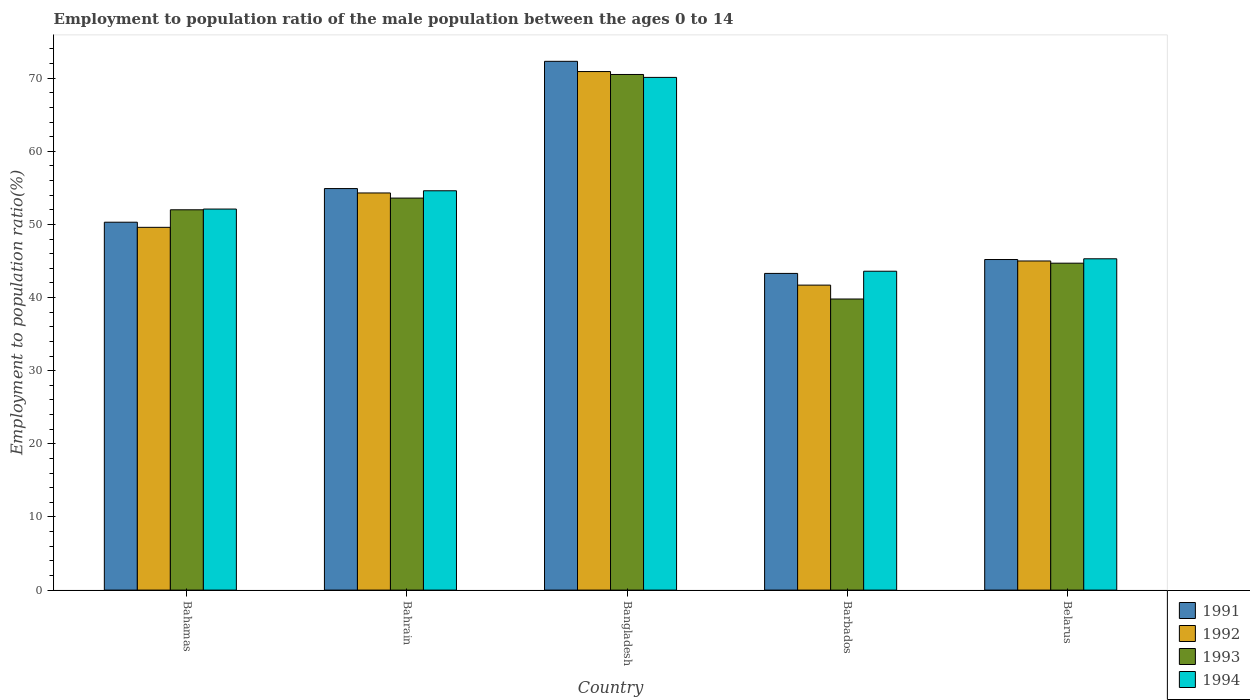Are the number of bars per tick equal to the number of legend labels?
Your answer should be very brief. Yes. Are the number of bars on each tick of the X-axis equal?
Ensure brevity in your answer.  Yes. How many bars are there on the 4th tick from the left?
Offer a very short reply. 4. What is the employment to population ratio in 1991 in Barbados?
Provide a succinct answer. 43.3. Across all countries, what is the maximum employment to population ratio in 1992?
Make the answer very short. 70.9. Across all countries, what is the minimum employment to population ratio in 1993?
Offer a terse response. 39.8. In which country was the employment to population ratio in 1993 maximum?
Your answer should be very brief. Bangladesh. In which country was the employment to population ratio in 1993 minimum?
Ensure brevity in your answer.  Barbados. What is the total employment to population ratio in 1994 in the graph?
Your answer should be very brief. 265.7. What is the difference between the employment to population ratio in 1993 in Bahrain and that in Belarus?
Keep it short and to the point. 8.9. What is the difference between the employment to population ratio in 1993 in Barbados and the employment to population ratio in 1992 in Belarus?
Make the answer very short. -5.2. What is the average employment to population ratio in 1991 per country?
Your answer should be compact. 53.2. What is the difference between the employment to population ratio of/in 1992 and employment to population ratio of/in 1991 in Belarus?
Your response must be concise. -0.2. In how many countries, is the employment to population ratio in 1991 greater than 56 %?
Offer a very short reply. 1. What is the ratio of the employment to population ratio in 1991 in Barbados to that in Belarus?
Your answer should be compact. 0.96. What is the difference between the highest and the second highest employment to population ratio in 1993?
Your response must be concise. -1.6. What is the difference between the highest and the lowest employment to population ratio in 1994?
Your response must be concise. 26.5. In how many countries, is the employment to population ratio in 1992 greater than the average employment to population ratio in 1992 taken over all countries?
Provide a short and direct response. 2. Is it the case that in every country, the sum of the employment to population ratio in 1992 and employment to population ratio in 1991 is greater than the sum of employment to population ratio in 1993 and employment to population ratio in 1994?
Your response must be concise. No. What does the 1st bar from the left in Barbados represents?
Give a very brief answer. 1991. Does the graph contain any zero values?
Provide a succinct answer. No. How many legend labels are there?
Your answer should be very brief. 4. How are the legend labels stacked?
Your answer should be compact. Vertical. What is the title of the graph?
Your response must be concise. Employment to population ratio of the male population between the ages 0 to 14. Does "1979" appear as one of the legend labels in the graph?
Your answer should be very brief. No. What is the label or title of the X-axis?
Provide a short and direct response. Country. What is the label or title of the Y-axis?
Offer a terse response. Employment to population ratio(%). What is the Employment to population ratio(%) in 1991 in Bahamas?
Provide a succinct answer. 50.3. What is the Employment to population ratio(%) of 1992 in Bahamas?
Offer a terse response. 49.6. What is the Employment to population ratio(%) of 1993 in Bahamas?
Provide a succinct answer. 52. What is the Employment to population ratio(%) in 1994 in Bahamas?
Your answer should be very brief. 52.1. What is the Employment to population ratio(%) in 1991 in Bahrain?
Provide a succinct answer. 54.9. What is the Employment to population ratio(%) of 1992 in Bahrain?
Offer a very short reply. 54.3. What is the Employment to population ratio(%) of 1993 in Bahrain?
Provide a succinct answer. 53.6. What is the Employment to population ratio(%) in 1994 in Bahrain?
Give a very brief answer. 54.6. What is the Employment to population ratio(%) of 1991 in Bangladesh?
Provide a succinct answer. 72.3. What is the Employment to population ratio(%) in 1992 in Bangladesh?
Give a very brief answer. 70.9. What is the Employment to population ratio(%) in 1993 in Bangladesh?
Your answer should be very brief. 70.5. What is the Employment to population ratio(%) in 1994 in Bangladesh?
Make the answer very short. 70.1. What is the Employment to population ratio(%) in 1991 in Barbados?
Provide a short and direct response. 43.3. What is the Employment to population ratio(%) in 1992 in Barbados?
Provide a short and direct response. 41.7. What is the Employment to population ratio(%) of 1993 in Barbados?
Keep it short and to the point. 39.8. What is the Employment to population ratio(%) of 1994 in Barbados?
Your answer should be compact. 43.6. What is the Employment to population ratio(%) of 1991 in Belarus?
Your response must be concise. 45.2. What is the Employment to population ratio(%) of 1993 in Belarus?
Offer a very short reply. 44.7. What is the Employment to population ratio(%) of 1994 in Belarus?
Keep it short and to the point. 45.3. Across all countries, what is the maximum Employment to population ratio(%) in 1991?
Keep it short and to the point. 72.3. Across all countries, what is the maximum Employment to population ratio(%) in 1992?
Make the answer very short. 70.9. Across all countries, what is the maximum Employment to population ratio(%) in 1993?
Offer a terse response. 70.5. Across all countries, what is the maximum Employment to population ratio(%) of 1994?
Your answer should be very brief. 70.1. Across all countries, what is the minimum Employment to population ratio(%) in 1991?
Provide a short and direct response. 43.3. Across all countries, what is the minimum Employment to population ratio(%) in 1992?
Keep it short and to the point. 41.7. Across all countries, what is the minimum Employment to population ratio(%) in 1993?
Give a very brief answer. 39.8. Across all countries, what is the minimum Employment to population ratio(%) of 1994?
Give a very brief answer. 43.6. What is the total Employment to population ratio(%) of 1991 in the graph?
Offer a very short reply. 266. What is the total Employment to population ratio(%) of 1992 in the graph?
Give a very brief answer. 261.5. What is the total Employment to population ratio(%) of 1993 in the graph?
Keep it short and to the point. 260.6. What is the total Employment to population ratio(%) of 1994 in the graph?
Give a very brief answer. 265.7. What is the difference between the Employment to population ratio(%) of 1991 in Bahamas and that in Bahrain?
Provide a succinct answer. -4.6. What is the difference between the Employment to population ratio(%) of 1993 in Bahamas and that in Bahrain?
Offer a terse response. -1.6. What is the difference between the Employment to population ratio(%) in 1994 in Bahamas and that in Bahrain?
Give a very brief answer. -2.5. What is the difference between the Employment to population ratio(%) of 1992 in Bahamas and that in Bangladesh?
Your response must be concise. -21.3. What is the difference between the Employment to population ratio(%) of 1993 in Bahamas and that in Bangladesh?
Your response must be concise. -18.5. What is the difference between the Employment to population ratio(%) in 1994 in Bahamas and that in Bangladesh?
Your answer should be very brief. -18. What is the difference between the Employment to population ratio(%) of 1991 in Bahamas and that in Barbados?
Your answer should be compact. 7. What is the difference between the Employment to population ratio(%) in 1991 in Bahamas and that in Belarus?
Make the answer very short. 5.1. What is the difference between the Employment to population ratio(%) in 1992 in Bahamas and that in Belarus?
Keep it short and to the point. 4.6. What is the difference between the Employment to population ratio(%) of 1993 in Bahamas and that in Belarus?
Provide a short and direct response. 7.3. What is the difference between the Employment to population ratio(%) of 1991 in Bahrain and that in Bangladesh?
Ensure brevity in your answer.  -17.4. What is the difference between the Employment to population ratio(%) in 1992 in Bahrain and that in Bangladesh?
Ensure brevity in your answer.  -16.6. What is the difference between the Employment to population ratio(%) in 1993 in Bahrain and that in Bangladesh?
Offer a very short reply. -16.9. What is the difference between the Employment to population ratio(%) of 1994 in Bahrain and that in Bangladesh?
Your answer should be very brief. -15.5. What is the difference between the Employment to population ratio(%) of 1991 in Bahrain and that in Belarus?
Provide a short and direct response. 9.7. What is the difference between the Employment to population ratio(%) in 1992 in Bahrain and that in Belarus?
Offer a terse response. 9.3. What is the difference between the Employment to population ratio(%) of 1992 in Bangladesh and that in Barbados?
Provide a succinct answer. 29.2. What is the difference between the Employment to population ratio(%) in 1993 in Bangladesh and that in Barbados?
Provide a succinct answer. 30.7. What is the difference between the Employment to population ratio(%) in 1994 in Bangladesh and that in Barbados?
Your answer should be compact. 26.5. What is the difference between the Employment to population ratio(%) in 1991 in Bangladesh and that in Belarus?
Offer a terse response. 27.1. What is the difference between the Employment to population ratio(%) in 1992 in Bangladesh and that in Belarus?
Offer a terse response. 25.9. What is the difference between the Employment to population ratio(%) of 1993 in Bangladesh and that in Belarus?
Your response must be concise. 25.8. What is the difference between the Employment to population ratio(%) of 1994 in Bangladesh and that in Belarus?
Make the answer very short. 24.8. What is the difference between the Employment to population ratio(%) in 1991 in Barbados and that in Belarus?
Offer a terse response. -1.9. What is the difference between the Employment to population ratio(%) in 1993 in Barbados and that in Belarus?
Provide a short and direct response. -4.9. What is the difference between the Employment to population ratio(%) in 1994 in Barbados and that in Belarus?
Give a very brief answer. -1.7. What is the difference between the Employment to population ratio(%) in 1991 in Bahamas and the Employment to population ratio(%) in 1992 in Bahrain?
Your answer should be very brief. -4. What is the difference between the Employment to population ratio(%) of 1991 in Bahamas and the Employment to population ratio(%) of 1993 in Bahrain?
Your response must be concise. -3.3. What is the difference between the Employment to population ratio(%) of 1991 in Bahamas and the Employment to population ratio(%) of 1994 in Bahrain?
Give a very brief answer. -4.3. What is the difference between the Employment to population ratio(%) in 1992 in Bahamas and the Employment to population ratio(%) in 1993 in Bahrain?
Ensure brevity in your answer.  -4. What is the difference between the Employment to population ratio(%) in 1991 in Bahamas and the Employment to population ratio(%) in 1992 in Bangladesh?
Give a very brief answer. -20.6. What is the difference between the Employment to population ratio(%) of 1991 in Bahamas and the Employment to population ratio(%) of 1993 in Bangladesh?
Provide a short and direct response. -20.2. What is the difference between the Employment to population ratio(%) in 1991 in Bahamas and the Employment to population ratio(%) in 1994 in Bangladesh?
Provide a short and direct response. -19.8. What is the difference between the Employment to population ratio(%) in 1992 in Bahamas and the Employment to population ratio(%) in 1993 in Bangladesh?
Your answer should be compact. -20.9. What is the difference between the Employment to population ratio(%) in 1992 in Bahamas and the Employment to population ratio(%) in 1994 in Bangladesh?
Your answer should be compact. -20.5. What is the difference between the Employment to population ratio(%) in 1993 in Bahamas and the Employment to population ratio(%) in 1994 in Bangladesh?
Provide a succinct answer. -18.1. What is the difference between the Employment to population ratio(%) in 1992 in Bahamas and the Employment to population ratio(%) in 1994 in Barbados?
Make the answer very short. 6. What is the difference between the Employment to population ratio(%) in 1993 in Bahamas and the Employment to population ratio(%) in 1994 in Barbados?
Offer a very short reply. 8.4. What is the difference between the Employment to population ratio(%) of 1991 in Bahamas and the Employment to population ratio(%) of 1993 in Belarus?
Make the answer very short. 5.6. What is the difference between the Employment to population ratio(%) of 1992 in Bahamas and the Employment to population ratio(%) of 1993 in Belarus?
Ensure brevity in your answer.  4.9. What is the difference between the Employment to population ratio(%) in 1992 in Bahamas and the Employment to population ratio(%) in 1994 in Belarus?
Provide a short and direct response. 4.3. What is the difference between the Employment to population ratio(%) of 1991 in Bahrain and the Employment to population ratio(%) of 1992 in Bangladesh?
Offer a very short reply. -16. What is the difference between the Employment to population ratio(%) in 1991 in Bahrain and the Employment to population ratio(%) in 1993 in Bangladesh?
Ensure brevity in your answer.  -15.6. What is the difference between the Employment to population ratio(%) of 1991 in Bahrain and the Employment to population ratio(%) of 1994 in Bangladesh?
Make the answer very short. -15.2. What is the difference between the Employment to population ratio(%) of 1992 in Bahrain and the Employment to population ratio(%) of 1993 in Bangladesh?
Your answer should be very brief. -16.2. What is the difference between the Employment to population ratio(%) of 1992 in Bahrain and the Employment to population ratio(%) of 1994 in Bangladesh?
Your answer should be very brief. -15.8. What is the difference between the Employment to population ratio(%) of 1993 in Bahrain and the Employment to population ratio(%) of 1994 in Bangladesh?
Keep it short and to the point. -16.5. What is the difference between the Employment to population ratio(%) in 1991 in Bahrain and the Employment to population ratio(%) in 1992 in Barbados?
Offer a terse response. 13.2. What is the difference between the Employment to population ratio(%) of 1992 in Bahrain and the Employment to population ratio(%) of 1993 in Barbados?
Provide a succinct answer. 14.5. What is the difference between the Employment to population ratio(%) of 1993 in Bahrain and the Employment to population ratio(%) of 1994 in Barbados?
Your response must be concise. 10. What is the difference between the Employment to population ratio(%) in 1992 in Bahrain and the Employment to population ratio(%) in 1993 in Belarus?
Your answer should be very brief. 9.6. What is the difference between the Employment to population ratio(%) of 1991 in Bangladesh and the Employment to population ratio(%) of 1992 in Barbados?
Keep it short and to the point. 30.6. What is the difference between the Employment to population ratio(%) in 1991 in Bangladesh and the Employment to population ratio(%) in 1993 in Barbados?
Keep it short and to the point. 32.5. What is the difference between the Employment to population ratio(%) in 1991 in Bangladesh and the Employment to population ratio(%) in 1994 in Barbados?
Offer a very short reply. 28.7. What is the difference between the Employment to population ratio(%) in 1992 in Bangladesh and the Employment to population ratio(%) in 1993 in Barbados?
Make the answer very short. 31.1. What is the difference between the Employment to population ratio(%) of 1992 in Bangladesh and the Employment to population ratio(%) of 1994 in Barbados?
Your answer should be compact. 27.3. What is the difference between the Employment to population ratio(%) in 1993 in Bangladesh and the Employment to population ratio(%) in 1994 in Barbados?
Provide a succinct answer. 26.9. What is the difference between the Employment to population ratio(%) in 1991 in Bangladesh and the Employment to population ratio(%) in 1992 in Belarus?
Offer a terse response. 27.3. What is the difference between the Employment to population ratio(%) in 1991 in Bangladesh and the Employment to population ratio(%) in 1993 in Belarus?
Provide a short and direct response. 27.6. What is the difference between the Employment to population ratio(%) of 1992 in Bangladesh and the Employment to population ratio(%) of 1993 in Belarus?
Your response must be concise. 26.2. What is the difference between the Employment to population ratio(%) of 1992 in Bangladesh and the Employment to population ratio(%) of 1994 in Belarus?
Your answer should be compact. 25.6. What is the difference between the Employment to population ratio(%) in 1993 in Bangladesh and the Employment to population ratio(%) in 1994 in Belarus?
Provide a succinct answer. 25.2. What is the difference between the Employment to population ratio(%) of 1991 in Barbados and the Employment to population ratio(%) of 1992 in Belarus?
Provide a short and direct response. -1.7. What is the difference between the Employment to population ratio(%) in 1992 in Barbados and the Employment to population ratio(%) in 1993 in Belarus?
Ensure brevity in your answer.  -3. What is the difference between the Employment to population ratio(%) of 1992 in Barbados and the Employment to population ratio(%) of 1994 in Belarus?
Your answer should be very brief. -3.6. What is the difference between the Employment to population ratio(%) in 1993 in Barbados and the Employment to population ratio(%) in 1994 in Belarus?
Ensure brevity in your answer.  -5.5. What is the average Employment to population ratio(%) in 1991 per country?
Your answer should be very brief. 53.2. What is the average Employment to population ratio(%) in 1992 per country?
Ensure brevity in your answer.  52.3. What is the average Employment to population ratio(%) of 1993 per country?
Your answer should be very brief. 52.12. What is the average Employment to population ratio(%) in 1994 per country?
Provide a succinct answer. 53.14. What is the difference between the Employment to population ratio(%) of 1991 and Employment to population ratio(%) of 1993 in Bahamas?
Provide a short and direct response. -1.7. What is the difference between the Employment to population ratio(%) of 1991 and Employment to population ratio(%) of 1994 in Bahamas?
Your answer should be compact. -1.8. What is the difference between the Employment to population ratio(%) of 1992 and Employment to population ratio(%) of 1993 in Bahamas?
Provide a succinct answer. -2.4. What is the difference between the Employment to population ratio(%) of 1992 and Employment to population ratio(%) of 1994 in Bahamas?
Offer a terse response. -2.5. What is the difference between the Employment to population ratio(%) in 1993 and Employment to population ratio(%) in 1994 in Bahamas?
Offer a very short reply. -0.1. What is the difference between the Employment to population ratio(%) in 1992 and Employment to population ratio(%) in 1993 in Bahrain?
Ensure brevity in your answer.  0.7. What is the difference between the Employment to population ratio(%) in 1991 and Employment to population ratio(%) in 1992 in Bangladesh?
Give a very brief answer. 1.4. What is the difference between the Employment to population ratio(%) in 1991 and Employment to population ratio(%) in 1993 in Bangladesh?
Make the answer very short. 1.8. What is the difference between the Employment to population ratio(%) in 1992 and Employment to population ratio(%) in 1993 in Bangladesh?
Provide a short and direct response. 0.4. What is the difference between the Employment to population ratio(%) of 1993 and Employment to population ratio(%) of 1994 in Bangladesh?
Give a very brief answer. 0.4. What is the difference between the Employment to population ratio(%) in 1991 and Employment to population ratio(%) in 1992 in Barbados?
Make the answer very short. 1.6. What is the difference between the Employment to population ratio(%) in 1991 and Employment to population ratio(%) in 1993 in Barbados?
Give a very brief answer. 3.5. What is the difference between the Employment to population ratio(%) in 1991 and Employment to population ratio(%) in 1994 in Barbados?
Your answer should be compact. -0.3. What is the difference between the Employment to population ratio(%) of 1992 and Employment to population ratio(%) of 1993 in Barbados?
Ensure brevity in your answer.  1.9. What is the difference between the Employment to population ratio(%) in 1991 and Employment to population ratio(%) in 1992 in Belarus?
Ensure brevity in your answer.  0.2. What is the difference between the Employment to population ratio(%) of 1991 and Employment to population ratio(%) of 1993 in Belarus?
Make the answer very short. 0.5. What is the difference between the Employment to population ratio(%) in 1991 and Employment to population ratio(%) in 1994 in Belarus?
Give a very brief answer. -0.1. What is the difference between the Employment to population ratio(%) of 1992 and Employment to population ratio(%) of 1993 in Belarus?
Make the answer very short. 0.3. What is the difference between the Employment to population ratio(%) of 1993 and Employment to population ratio(%) of 1994 in Belarus?
Ensure brevity in your answer.  -0.6. What is the ratio of the Employment to population ratio(%) in 1991 in Bahamas to that in Bahrain?
Keep it short and to the point. 0.92. What is the ratio of the Employment to population ratio(%) in 1992 in Bahamas to that in Bahrain?
Offer a very short reply. 0.91. What is the ratio of the Employment to population ratio(%) of 1993 in Bahamas to that in Bahrain?
Make the answer very short. 0.97. What is the ratio of the Employment to population ratio(%) of 1994 in Bahamas to that in Bahrain?
Your answer should be compact. 0.95. What is the ratio of the Employment to population ratio(%) of 1991 in Bahamas to that in Bangladesh?
Keep it short and to the point. 0.7. What is the ratio of the Employment to population ratio(%) of 1992 in Bahamas to that in Bangladesh?
Ensure brevity in your answer.  0.7. What is the ratio of the Employment to population ratio(%) of 1993 in Bahamas to that in Bangladesh?
Give a very brief answer. 0.74. What is the ratio of the Employment to population ratio(%) of 1994 in Bahamas to that in Bangladesh?
Provide a succinct answer. 0.74. What is the ratio of the Employment to population ratio(%) of 1991 in Bahamas to that in Barbados?
Offer a terse response. 1.16. What is the ratio of the Employment to population ratio(%) in 1992 in Bahamas to that in Barbados?
Your answer should be compact. 1.19. What is the ratio of the Employment to population ratio(%) of 1993 in Bahamas to that in Barbados?
Provide a succinct answer. 1.31. What is the ratio of the Employment to population ratio(%) in 1994 in Bahamas to that in Barbados?
Keep it short and to the point. 1.2. What is the ratio of the Employment to population ratio(%) of 1991 in Bahamas to that in Belarus?
Give a very brief answer. 1.11. What is the ratio of the Employment to population ratio(%) of 1992 in Bahamas to that in Belarus?
Your answer should be compact. 1.1. What is the ratio of the Employment to population ratio(%) of 1993 in Bahamas to that in Belarus?
Offer a terse response. 1.16. What is the ratio of the Employment to population ratio(%) of 1994 in Bahamas to that in Belarus?
Provide a short and direct response. 1.15. What is the ratio of the Employment to population ratio(%) of 1991 in Bahrain to that in Bangladesh?
Your answer should be very brief. 0.76. What is the ratio of the Employment to population ratio(%) of 1992 in Bahrain to that in Bangladesh?
Provide a short and direct response. 0.77. What is the ratio of the Employment to population ratio(%) in 1993 in Bahrain to that in Bangladesh?
Provide a succinct answer. 0.76. What is the ratio of the Employment to population ratio(%) in 1994 in Bahrain to that in Bangladesh?
Keep it short and to the point. 0.78. What is the ratio of the Employment to population ratio(%) of 1991 in Bahrain to that in Barbados?
Offer a very short reply. 1.27. What is the ratio of the Employment to population ratio(%) in 1992 in Bahrain to that in Barbados?
Ensure brevity in your answer.  1.3. What is the ratio of the Employment to population ratio(%) of 1993 in Bahrain to that in Barbados?
Ensure brevity in your answer.  1.35. What is the ratio of the Employment to population ratio(%) in 1994 in Bahrain to that in Barbados?
Make the answer very short. 1.25. What is the ratio of the Employment to population ratio(%) in 1991 in Bahrain to that in Belarus?
Ensure brevity in your answer.  1.21. What is the ratio of the Employment to population ratio(%) in 1992 in Bahrain to that in Belarus?
Give a very brief answer. 1.21. What is the ratio of the Employment to population ratio(%) of 1993 in Bahrain to that in Belarus?
Offer a very short reply. 1.2. What is the ratio of the Employment to population ratio(%) in 1994 in Bahrain to that in Belarus?
Offer a very short reply. 1.21. What is the ratio of the Employment to population ratio(%) in 1991 in Bangladesh to that in Barbados?
Offer a terse response. 1.67. What is the ratio of the Employment to population ratio(%) in 1992 in Bangladesh to that in Barbados?
Your response must be concise. 1.7. What is the ratio of the Employment to population ratio(%) in 1993 in Bangladesh to that in Barbados?
Provide a short and direct response. 1.77. What is the ratio of the Employment to population ratio(%) in 1994 in Bangladesh to that in Barbados?
Give a very brief answer. 1.61. What is the ratio of the Employment to population ratio(%) of 1991 in Bangladesh to that in Belarus?
Your response must be concise. 1.6. What is the ratio of the Employment to population ratio(%) in 1992 in Bangladesh to that in Belarus?
Provide a short and direct response. 1.58. What is the ratio of the Employment to population ratio(%) of 1993 in Bangladesh to that in Belarus?
Your answer should be compact. 1.58. What is the ratio of the Employment to population ratio(%) of 1994 in Bangladesh to that in Belarus?
Offer a terse response. 1.55. What is the ratio of the Employment to population ratio(%) in 1991 in Barbados to that in Belarus?
Your response must be concise. 0.96. What is the ratio of the Employment to population ratio(%) of 1992 in Barbados to that in Belarus?
Keep it short and to the point. 0.93. What is the ratio of the Employment to population ratio(%) of 1993 in Barbados to that in Belarus?
Your response must be concise. 0.89. What is the ratio of the Employment to population ratio(%) in 1994 in Barbados to that in Belarus?
Make the answer very short. 0.96. What is the difference between the highest and the second highest Employment to population ratio(%) in 1993?
Keep it short and to the point. 16.9. What is the difference between the highest and the lowest Employment to population ratio(%) of 1991?
Give a very brief answer. 29. What is the difference between the highest and the lowest Employment to population ratio(%) in 1992?
Provide a succinct answer. 29.2. What is the difference between the highest and the lowest Employment to population ratio(%) in 1993?
Offer a terse response. 30.7. 